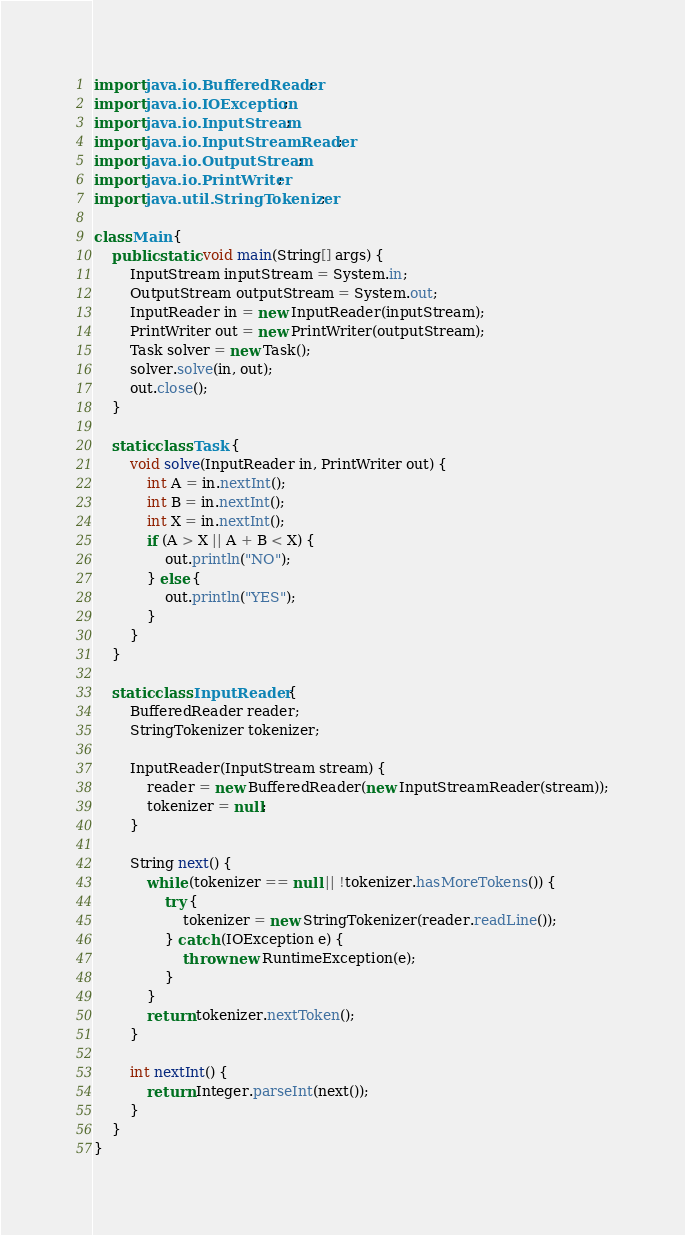Convert code to text. <code><loc_0><loc_0><loc_500><loc_500><_Java_>import java.io.BufferedReader;
import java.io.IOException;
import java.io.InputStream;
import java.io.InputStreamReader;
import java.io.OutputStream;
import java.io.PrintWriter;
import java.util.StringTokenizer;

class Main {
    public static void main(String[] args) {
        InputStream inputStream = System.in;
        OutputStream outputStream = System.out;
        InputReader in = new InputReader(inputStream);
        PrintWriter out = new PrintWriter(outputStream);
        Task solver = new Task();
        solver.solve(in, out);
        out.close();
    }

    static class Task {
        void solve(InputReader in, PrintWriter out) {
            int A = in.nextInt();
            int B = in.nextInt();
            int X = in.nextInt();
            if (A > X || A + B < X) {
                out.println("NO");
            } else {
                out.println("YES");
            }
        }
    }

    static class InputReader {
        BufferedReader reader;
        StringTokenizer tokenizer;

        InputReader(InputStream stream) {
            reader = new BufferedReader(new InputStreamReader(stream));
            tokenizer = null;
        }

        String next() {
            while (tokenizer == null || !tokenizer.hasMoreTokens()) {
                try {
                    tokenizer = new StringTokenizer(reader.readLine());
                } catch (IOException e) {
                    throw new RuntimeException(e);
                }
            }
            return tokenizer.nextToken();
        }

        int nextInt() {
            return Integer.parseInt(next());
        }
    }
}</code> 